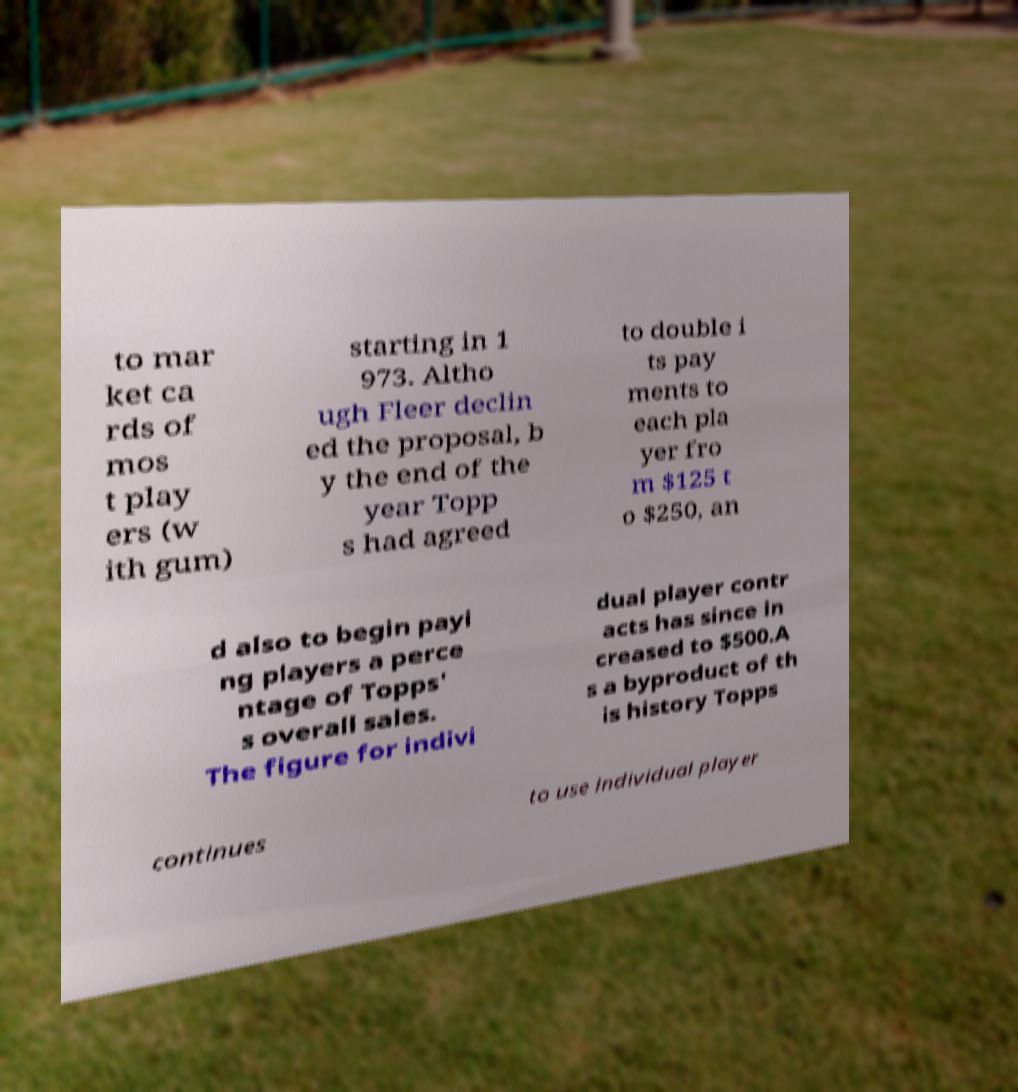There's text embedded in this image that I need extracted. Can you transcribe it verbatim? to mar ket ca rds of mos t play ers (w ith gum) starting in 1 973. Altho ugh Fleer declin ed the proposal, b y the end of the year Topp s had agreed to double i ts pay ments to each pla yer fro m $125 t o $250, an d also to begin payi ng players a perce ntage of Topps' s overall sales. The figure for indivi dual player contr acts has since in creased to $500.A s a byproduct of th is history Topps continues to use individual player 